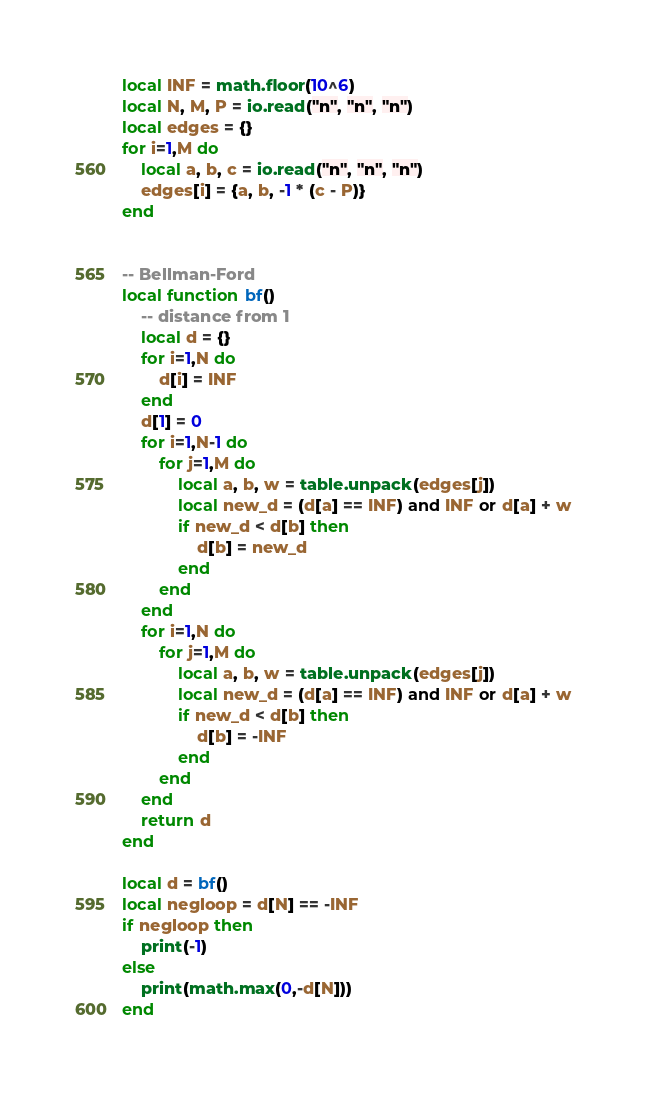<code> <loc_0><loc_0><loc_500><loc_500><_Lua_>local INF = math.floor(10^6)
local N, M, P = io.read("n", "n", "n")
local edges = {}
for i=1,M do
    local a, b, c = io.read("n", "n", "n")
    edges[i] = {a, b, -1 * (c - P)}
end


-- Bellman-Ford
local function bf()
    -- distance from 1
    local d = {}
    for i=1,N do
        d[i] = INF
    end
    d[1] = 0
    for i=1,N-1 do
        for j=1,M do
            local a, b, w = table.unpack(edges[j])
            local new_d = (d[a] == INF) and INF or d[a] + w
            if new_d < d[b] then
                d[b] = new_d
            end
        end
    end
    for i=1,N do
        for j=1,M do
            local a, b, w = table.unpack(edges[j])
            local new_d = (d[a] == INF) and INF or d[a] + w
            if new_d < d[b] then
                d[b] = -INF
            end
        end
    end
    return d
end

local d = bf()
local negloop = d[N] == -INF
if negloop then
    print(-1)
else
    print(math.max(0,-d[N]))
end</code> 